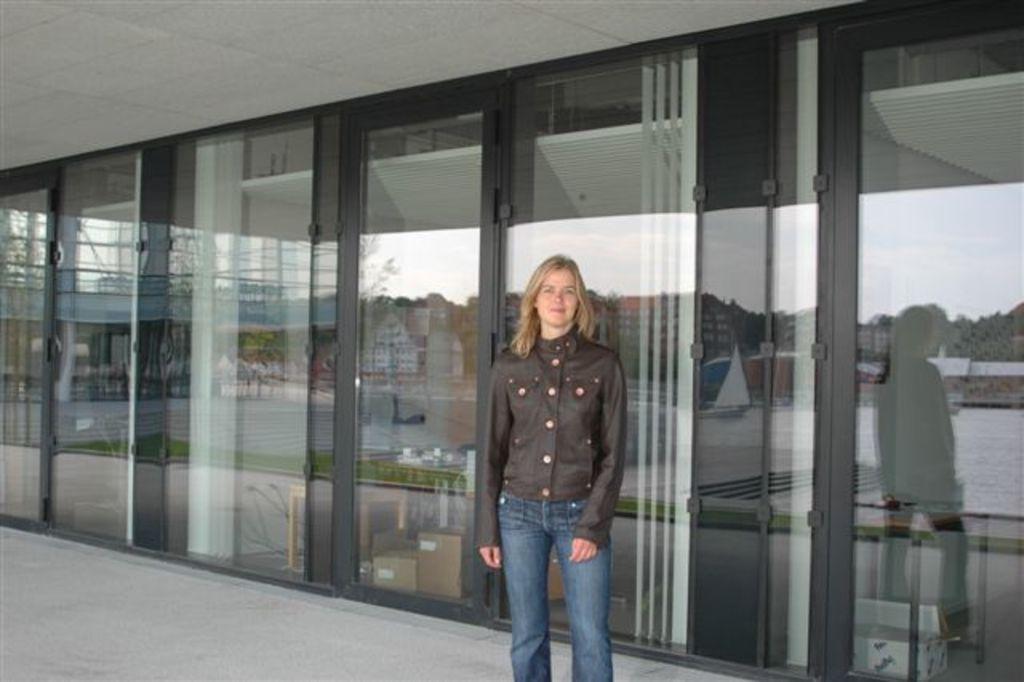Please provide a concise description of this image. In this picture we can see a woman standing on the path. There are a few glass objects. On these objects, we can see the reflections of a few houses, plants, a woman and other objects. 